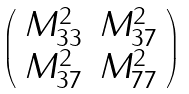Convert formula to latex. <formula><loc_0><loc_0><loc_500><loc_500>\left ( \begin{array} { c c } M _ { 3 3 } ^ { 2 } & M _ { 3 7 } ^ { 2 } \\ M _ { 3 7 } ^ { 2 } & M _ { 7 7 } ^ { 2 } \end{array} \right )</formula> 